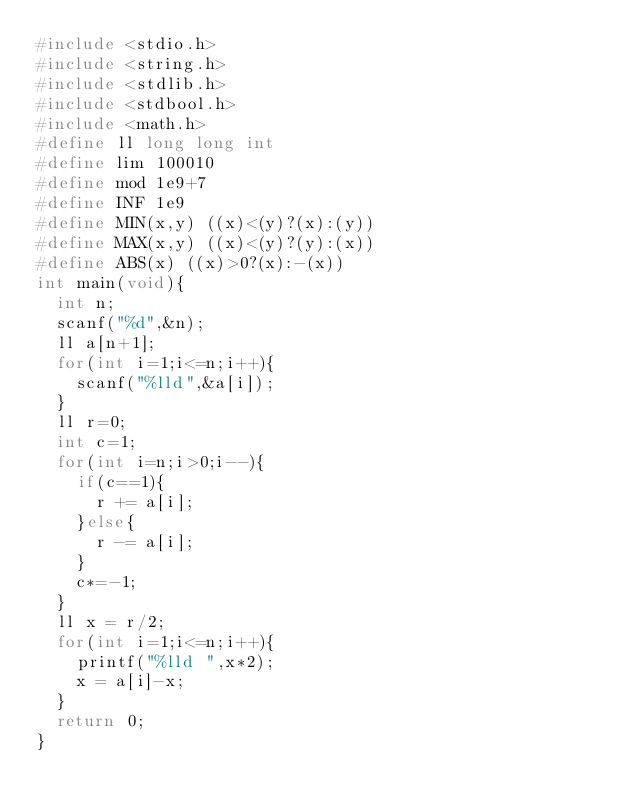Convert code to text. <code><loc_0><loc_0><loc_500><loc_500><_C_>#include <stdio.h>
#include <string.h>
#include <stdlib.h>
#include <stdbool.h>
#include <math.h>
#define ll long long int
#define lim 100010
#define mod 1e9+7
#define INF 1e9
#define MIN(x,y) ((x)<(y)?(x):(y))
#define MAX(x,y) ((x)<(y)?(y):(x))
#define ABS(x) ((x)>0?(x):-(x))
int main(void){
	int n;
	scanf("%d",&n);
	ll a[n+1];
	for(int i=1;i<=n;i++){
		scanf("%lld",&a[i]);
	}
	ll r=0;
	int c=1;
	for(int i=n;i>0;i--){
		if(c==1){
			r += a[i];
		}else{
			r -= a[i];
		}
		c*=-1;
	}
	ll x = r/2;
	for(int i=1;i<=n;i++){
		printf("%lld ",x*2);
		x = a[i]-x;
	}
	return 0;
}</code> 